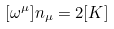Convert formula to latex. <formula><loc_0><loc_0><loc_500><loc_500>[ \omega ^ { \mu } ] n _ { \mu } = 2 [ K ]</formula> 